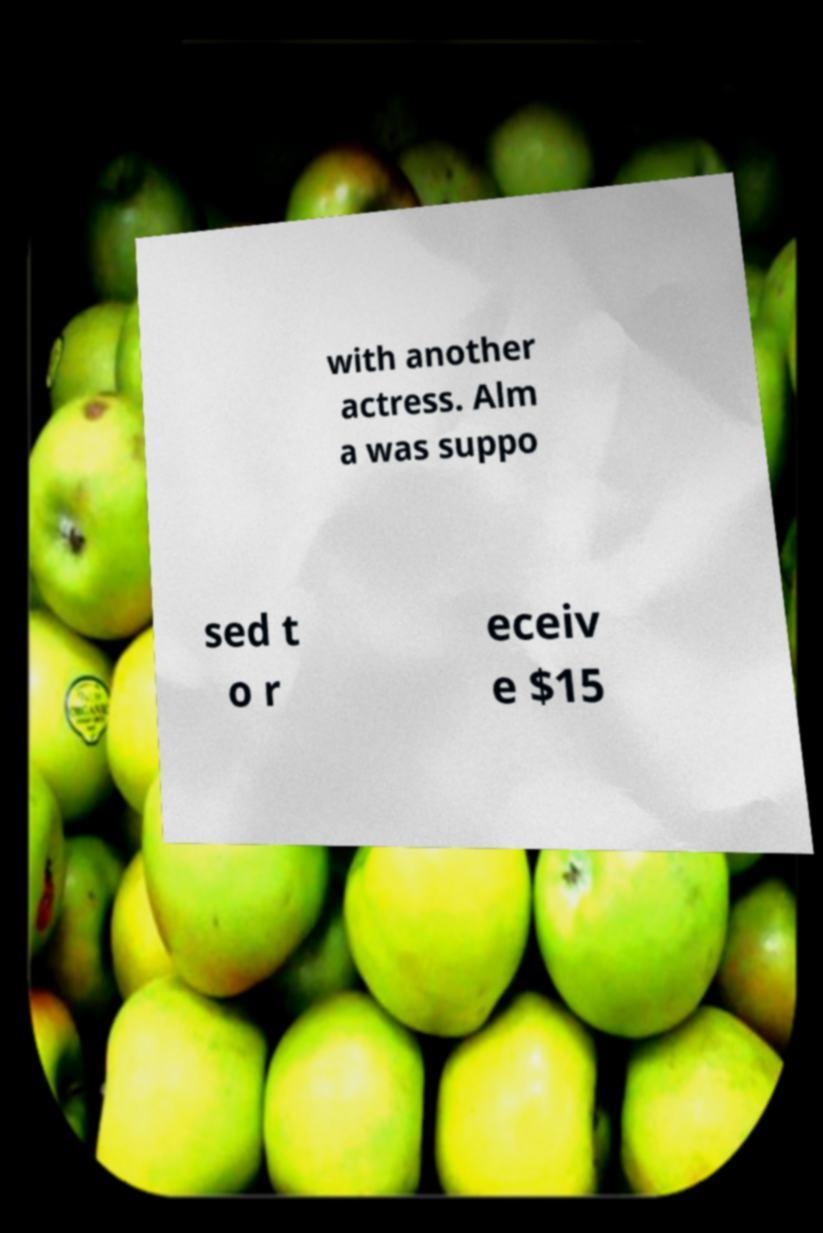Can you accurately transcribe the text from the provided image for me? with another actress. Alm a was suppo sed t o r eceiv e $15 